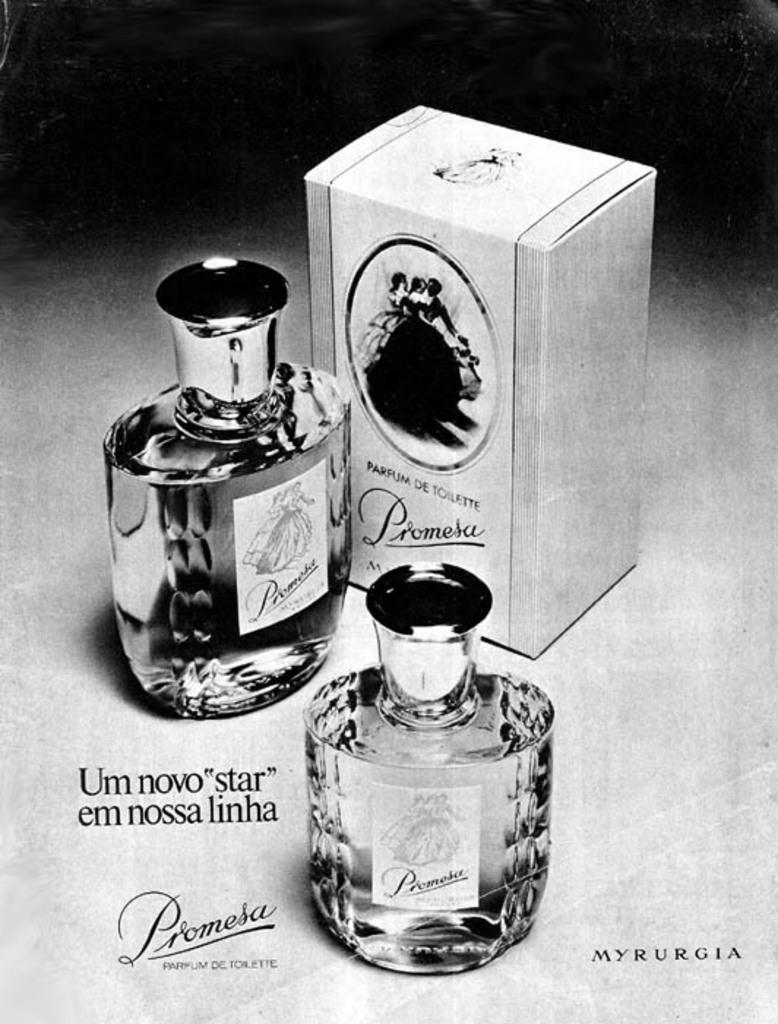<image>
Give a short and clear explanation of the subsequent image. Two bottles of Promesa branded perfume with the box sitting next to them. 